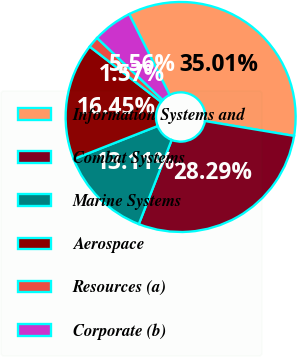<chart> <loc_0><loc_0><loc_500><loc_500><pie_chart><fcel>Information Systems and<fcel>Combat Systems<fcel>Marine Systems<fcel>Aerospace<fcel>Resources (a)<fcel>Corporate (b)<nl><fcel>35.01%<fcel>28.29%<fcel>13.11%<fcel>16.45%<fcel>1.57%<fcel>5.56%<nl></chart> 